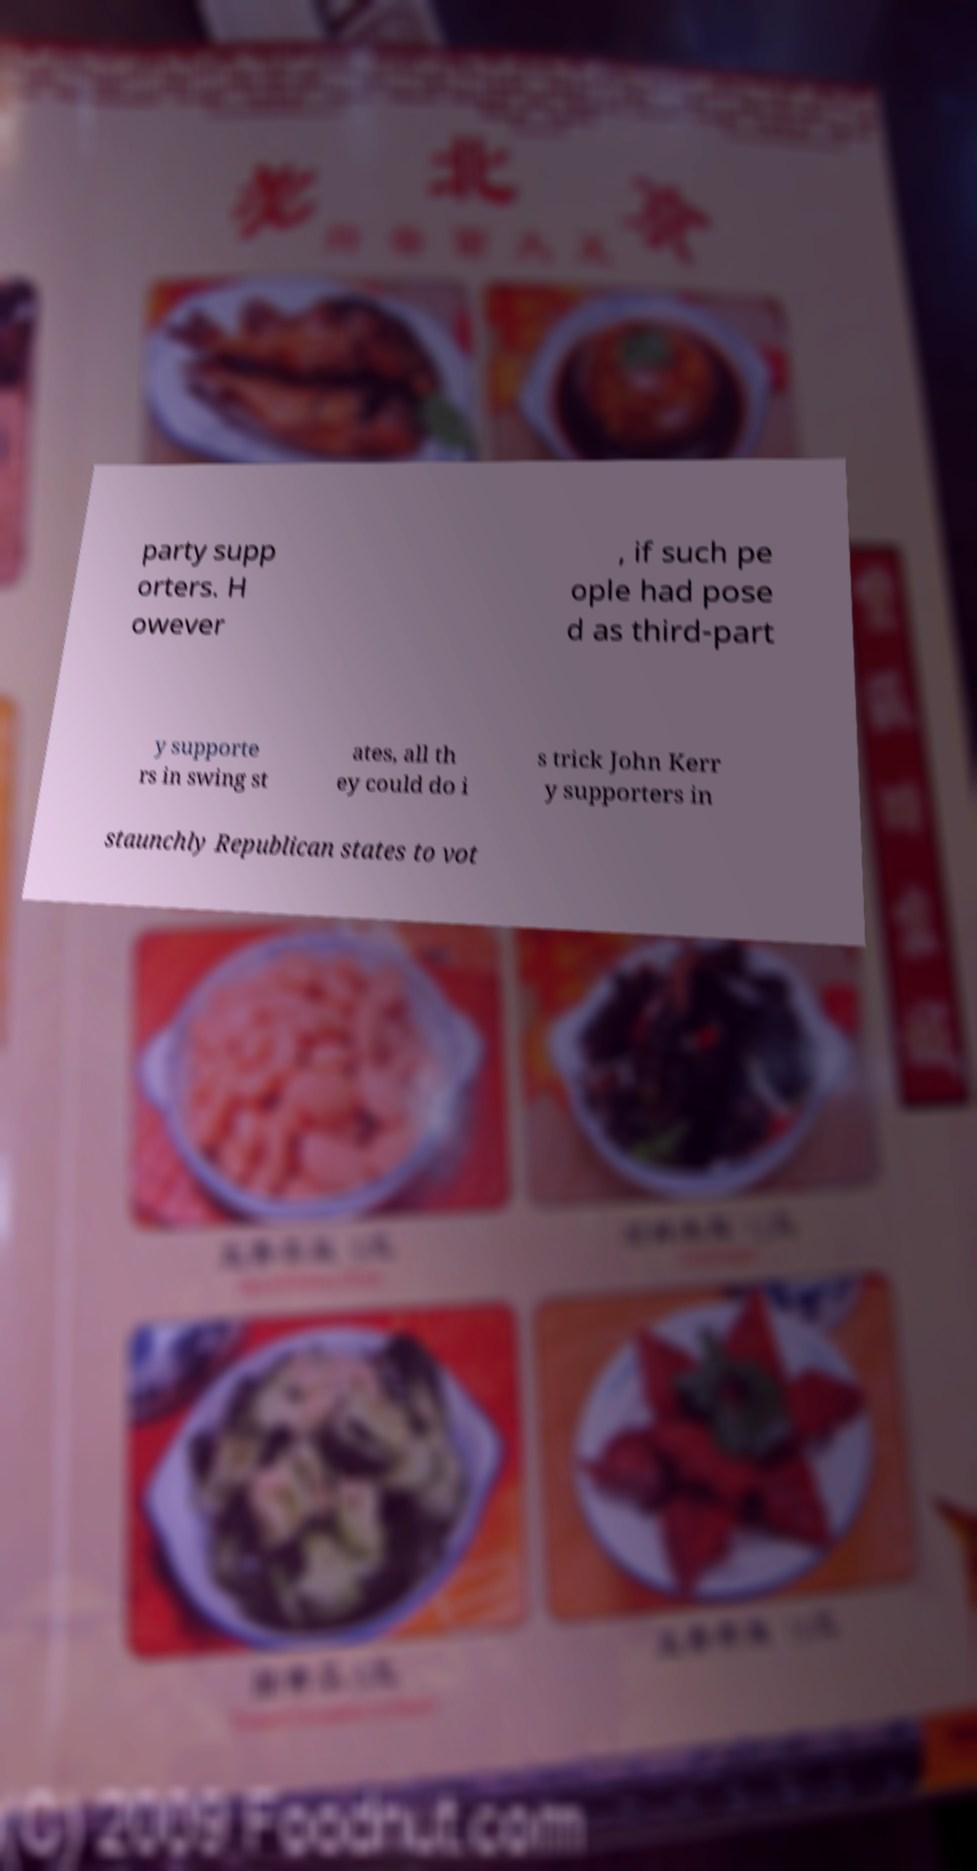Could you assist in decoding the text presented in this image and type it out clearly? party supp orters. H owever , if such pe ople had pose d as third-part y supporte rs in swing st ates, all th ey could do i s trick John Kerr y supporters in staunchly Republican states to vot 